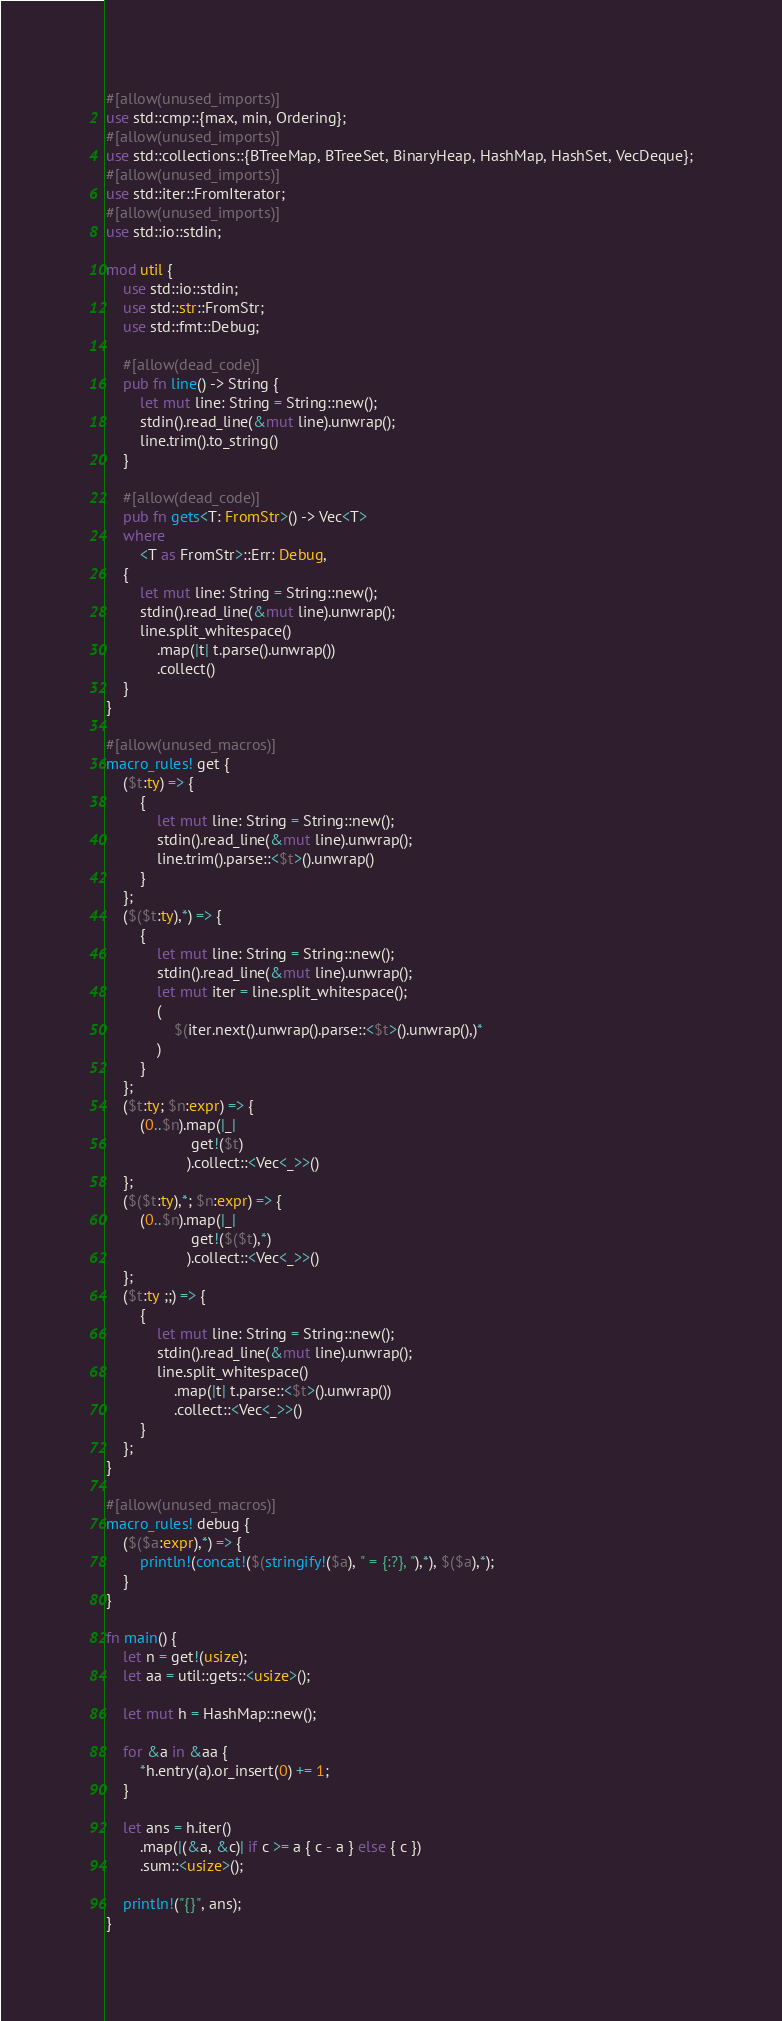Convert code to text. <code><loc_0><loc_0><loc_500><loc_500><_Rust_>#[allow(unused_imports)]
use std::cmp::{max, min, Ordering};
#[allow(unused_imports)]
use std::collections::{BTreeMap, BTreeSet, BinaryHeap, HashMap, HashSet, VecDeque};
#[allow(unused_imports)]
use std::iter::FromIterator;
#[allow(unused_imports)]
use std::io::stdin;

mod util {
    use std::io::stdin;
    use std::str::FromStr;
    use std::fmt::Debug;

    #[allow(dead_code)]
    pub fn line() -> String {
        let mut line: String = String::new();
        stdin().read_line(&mut line).unwrap();
        line.trim().to_string()
    }

    #[allow(dead_code)]
    pub fn gets<T: FromStr>() -> Vec<T>
    where
        <T as FromStr>::Err: Debug,
    {
        let mut line: String = String::new();
        stdin().read_line(&mut line).unwrap();
        line.split_whitespace()
            .map(|t| t.parse().unwrap())
            .collect()
    }
}

#[allow(unused_macros)]
macro_rules! get {
    ($t:ty) => {
        {
            let mut line: String = String::new();
            stdin().read_line(&mut line).unwrap();
            line.trim().parse::<$t>().unwrap()
        }
    };
    ($($t:ty),*) => {
        {
            let mut line: String = String::new();
            stdin().read_line(&mut line).unwrap();
            let mut iter = line.split_whitespace();
            (
                $(iter.next().unwrap().parse::<$t>().unwrap(),)*
            )
        }
    };
    ($t:ty; $n:expr) => {
        (0..$n).map(|_|
                    get!($t)
                   ).collect::<Vec<_>>()
    };
    ($($t:ty),*; $n:expr) => {
        (0..$n).map(|_|
                    get!($($t),*)
                   ).collect::<Vec<_>>()
    };
    ($t:ty ;;) => {
        {
            let mut line: String = String::new();
            stdin().read_line(&mut line).unwrap();
            line.split_whitespace()
                .map(|t| t.parse::<$t>().unwrap())
                .collect::<Vec<_>>()
        }
    };
}

#[allow(unused_macros)]
macro_rules! debug {
    ($($a:expr),*) => {
        println!(concat!($(stringify!($a), " = {:?}, "),*), $($a),*);
    }
}

fn main() {
    let n = get!(usize);
    let aa = util::gets::<usize>();

    let mut h = HashMap::new();

    for &a in &aa {
        *h.entry(a).or_insert(0) += 1;
    }

    let ans = h.iter()
        .map(|(&a, &c)| if c >= a { c - a } else { c })
        .sum::<usize>();

    println!("{}", ans);
}
</code> 